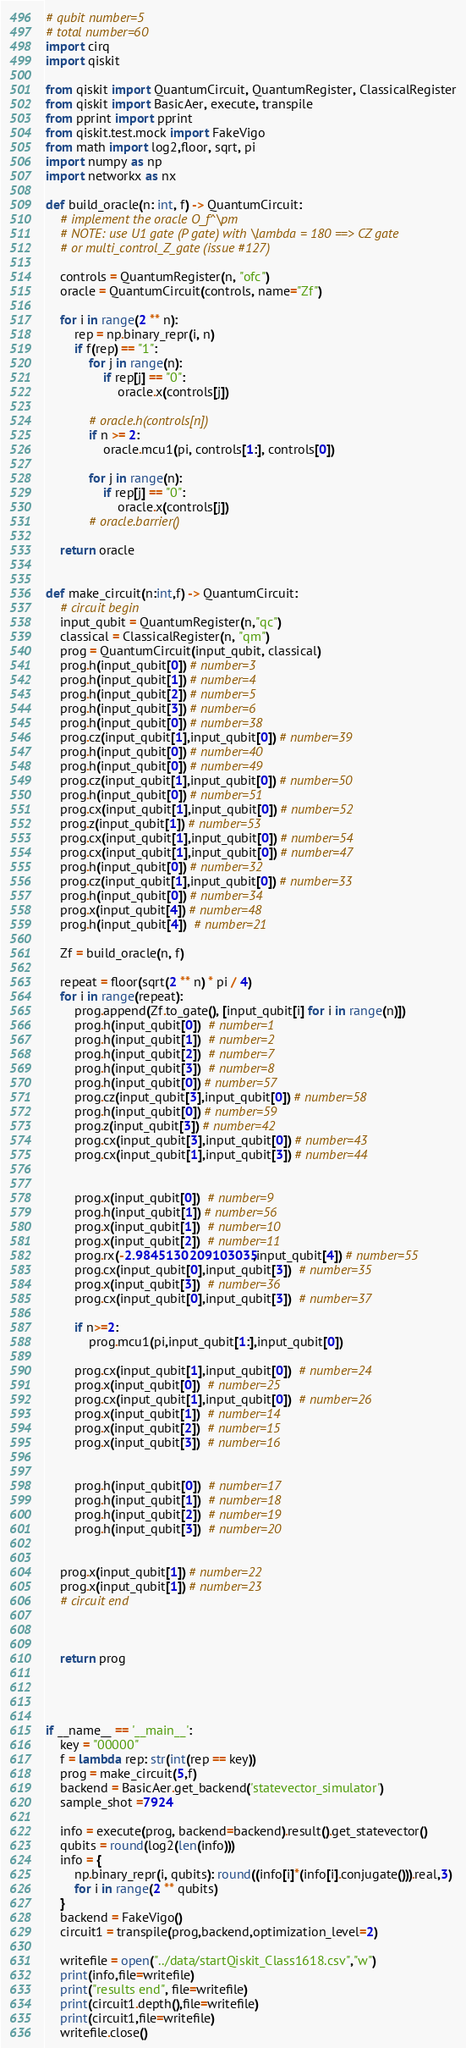Convert code to text. <code><loc_0><loc_0><loc_500><loc_500><_Python_># qubit number=5
# total number=60
import cirq
import qiskit

from qiskit import QuantumCircuit, QuantumRegister, ClassicalRegister
from qiskit import BasicAer, execute, transpile
from pprint import pprint
from qiskit.test.mock import FakeVigo
from math import log2,floor, sqrt, pi
import numpy as np
import networkx as nx

def build_oracle(n: int, f) -> QuantumCircuit:
    # implement the oracle O_f^\pm
    # NOTE: use U1 gate (P gate) with \lambda = 180 ==> CZ gate
    # or multi_control_Z_gate (issue #127)

    controls = QuantumRegister(n, "ofc")
    oracle = QuantumCircuit(controls, name="Zf")

    for i in range(2 ** n):
        rep = np.binary_repr(i, n)
        if f(rep) == "1":
            for j in range(n):
                if rep[j] == "0":
                    oracle.x(controls[j])

            # oracle.h(controls[n])
            if n >= 2:
                oracle.mcu1(pi, controls[1:], controls[0])

            for j in range(n):
                if rep[j] == "0":
                    oracle.x(controls[j])
            # oracle.barrier()

    return oracle


def make_circuit(n:int,f) -> QuantumCircuit:
    # circuit begin
    input_qubit = QuantumRegister(n,"qc")
    classical = ClassicalRegister(n, "qm")
    prog = QuantumCircuit(input_qubit, classical)
    prog.h(input_qubit[0]) # number=3
    prog.h(input_qubit[1]) # number=4
    prog.h(input_qubit[2]) # number=5
    prog.h(input_qubit[3]) # number=6
    prog.h(input_qubit[0]) # number=38
    prog.cz(input_qubit[1],input_qubit[0]) # number=39
    prog.h(input_qubit[0]) # number=40
    prog.h(input_qubit[0]) # number=49
    prog.cz(input_qubit[1],input_qubit[0]) # number=50
    prog.h(input_qubit[0]) # number=51
    prog.cx(input_qubit[1],input_qubit[0]) # number=52
    prog.z(input_qubit[1]) # number=53
    prog.cx(input_qubit[1],input_qubit[0]) # number=54
    prog.cx(input_qubit[1],input_qubit[0]) # number=47
    prog.h(input_qubit[0]) # number=32
    prog.cz(input_qubit[1],input_qubit[0]) # number=33
    prog.h(input_qubit[0]) # number=34
    prog.x(input_qubit[4]) # number=48
    prog.h(input_qubit[4])  # number=21

    Zf = build_oracle(n, f)

    repeat = floor(sqrt(2 ** n) * pi / 4)
    for i in range(repeat):
        prog.append(Zf.to_gate(), [input_qubit[i] for i in range(n)])
        prog.h(input_qubit[0])  # number=1
        prog.h(input_qubit[1])  # number=2
        prog.h(input_qubit[2])  # number=7
        prog.h(input_qubit[3])  # number=8
        prog.h(input_qubit[0]) # number=57
        prog.cz(input_qubit[3],input_qubit[0]) # number=58
        prog.h(input_qubit[0]) # number=59
        prog.z(input_qubit[3]) # number=42
        prog.cx(input_qubit[3],input_qubit[0]) # number=43
        prog.cx(input_qubit[1],input_qubit[3]) # number=44


        prog.x(input_qubit[0])  # number=9
        prog.h(input_qubit[1]) # number=56
        prog.x(input_qubit[1])  # number=10
        prog.x(input_qubit[2])  # number=11
        prog.rx(-2.9845130209103035,input_qubit[4]) # number=55
        prog.cx(input_qubit[0],input_qubit[3])  # number=35
        prog.x(input_qubit[3])  # number=36
        prog.cx(input_qubit[0],input_qubit[3])  # number=37

        if n>=2:
            prog.mcu1(pi,input_qubit[1:],input_qubit[0])

        prog.cx(input_qubit[1],input_qubit[0])  # number=24
        prog.x(input_qubit[0])  # number=25
        prog.cx(input_qubit[1],input_qubit[0])  # number=26
        prog.x(input_qubit[1])  # number=14
        prog.x(input_qubit[2])  # number=15
        prog.x(input_qubit[3])  # number=16


        prog.h(input_qubit[0])  # number=17
        prog.h(input_qubit[1])  # number=18
        prog.h(input_qubit[2])  # number=19
        prog.h(input_qubit[3])  # number=20


    prog.x(input_qubit[1]) # number=22
    prog.x(input_qubit[1]) # number=23
    # circuit end



    return prog




if __name__ == '__main__':
    key = "00000"
    f = lambda rep: str(int(rep == key))
    prog = make_circuit(5,f)
    backend = BasicAer.get_backend('statevector_simulator')
    sample_shot =7924

    info = execute(prog, backend=backend).result().get_statevector()
    qubits = round(log2(len(info)))
    info = {
        np.binary_repr(i, qubits): round((info[i]*(info[i].conjugate())).real,3)
        for i in range(2 ** qubits)
    }
    backend = FakeVigo()
    circuit1 = transpile(prog,backend,optimization_level=2)

    writefile = open("../data/startQiskit_Class1618.csv","w")
    print(info,file=writefile)
    print("results end", file=writefile)
    print(circuit1.depth(),file=writefile)
    print(circuit1,file=writefile)
    writefile.close()
</code> 